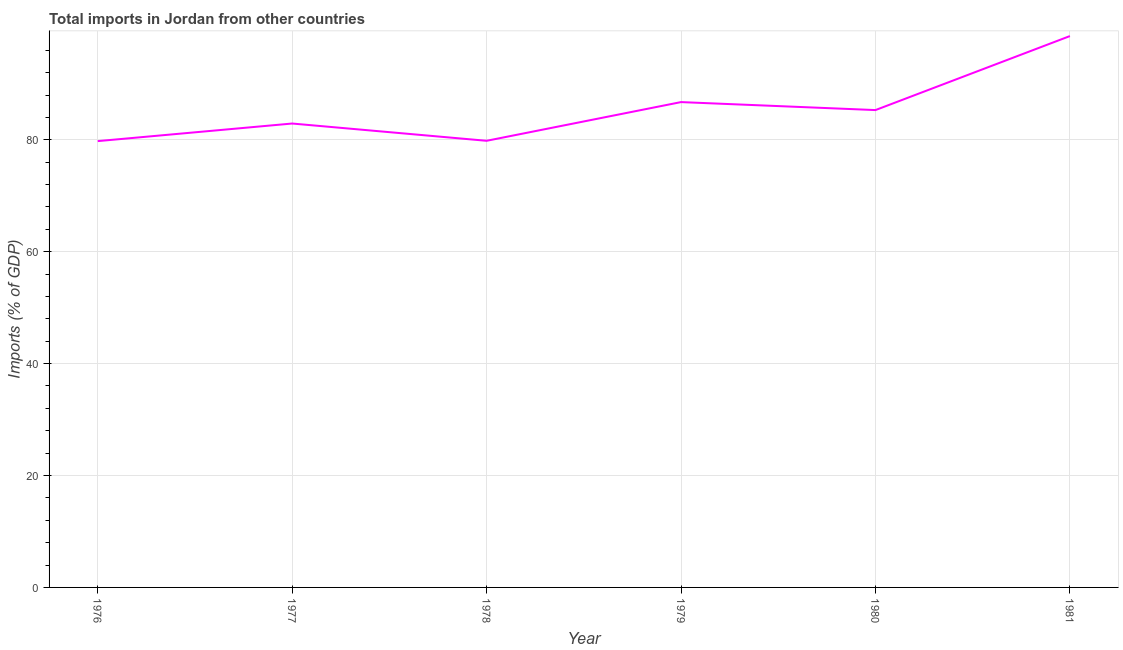What is the total imports in 1977?
Make the answer very short. 82.91. Across all years, what is the maximum total imports?
Give a very brief answer. 98.54. Across all years, what is the minimum total imports?
Provide a succinct answer. 79.76. In which year was the total imports maximum?
Provide a succinct answer. 1981. In which year was the total imports minimum?
Ensure brevity in your answer.  1976. What is the sum of the total imports?
Make the answer very short. 513.08. What is the difference between the total imports in 1977 and 1978?
Give a very brief answer. 3.09. What is the average total imports per year?
Give a very brief answer. 85.51. What is the median total imports?
Offer a terse response. 84.11. Do a majority of the years between 1979 and 1981 (inclusive) have total imports greater than 48 %?
Provide a short and direct response. Yes. What is the ratio of the total imports in 1976 to that in 1979?
Provide a short and direct response. 0.92. What is the difference between the highest and the second highest total imports?
Keep it short and to the point. 11.8. What is the difference between the highest and the lowest total imports?
Give a very brief answer. 18.77. Does the total imports monotonically increase over the years?
Your answer should be compact. No. How many lines are there?
Give a very brief answer. 1. How many years are there in the graph?
Give a very brief answer. 6. What is the difference between two consecutive major ticks on the Y-axis?
Your answer should be very brief. 20. Are the values on the major ticks of Y-axis written in scientific E-notation?
Keep it short and to the point. No. Does the graph contain any zero values?
Your response must be concise. No. What is the title of the graph?
Keep it short and to the point. Total imports in Jordan from other countries. What is the label or title of the X-axis?
Provide a succinct answer. Year. What is the label or title of the Y-axis?
Offer a terse response. Imports (% of GDP). What is the Imports (% of GDP) of 1976?
Provide a succinct answer. 79.76. What is the Imports (% of GDP) in 1977?
Offer a terse response. 82.91. What is the Imports (% of GDP) in 1978?
Make the answer very short. 79.82. What is the Imports (% of GDP) of 1979?
Keep it short and to the point. 86.74. What is the Imports (% of GDP) of 1980?
Make the answer very short. 85.31. What is the Imports (% of GDP) of 1981?
Provide a succinct answer. 98.54. What is the difference between the Imports (% of GDP) in 1976 and 1977?
Make the answer very short. -3.14. What is the difference between the Imports (% of GDP) in 1976 and 1978?
Your answer should be compact. -0.06. What is the difference between the Imports (% of GDP) in 1976 and 1979?
Your answer should be compact. -6.97. What is the difference between the Imports (% of GDP) in 1976 and 1980?
Your response must be concise. -5.55. What is the difference between the Imports (% of GDP) in 1976 and 1981?
Make the answer very short. -18.77. What is the difference between the Imports (% of GDP) in 1977 and 1978?
Give a very brief answer. 3.09. What is the difference between the Imports (% of GDP) in 1977 and 1979?
Offer a terse response. -3.83. What is the difference between the Imports (% of GDP) in 1977 and 1980?
Offer a very short reply. -2.4. What is the difference between the Imports (% of GDP) in 1977 and 1981?
Ensure brevity in your answer.  -15.63. What is the difference between the Imports (% of GDP) in 1978 and 1979?
Ensure brevity in your answer.  -6.92. What is the difference between the Imports (% of GDP) in 1978 and 1980?
Make the answer very short. -5.49. What is the difference between the Imports (% of GDP) in 1978 and 1981?
Offer a terse response. -18.72. What is the difference between the Imports (% of GDP) in 1979 and 1980?
Provide a succinct answer. 1.43. What is the difference between the Imports (% of GDP) in 1979 and 1981?
Offer a terse response. -11.8. What is the difference between the Imports (% of GDP) in 1980 and 1981?
Keep it short and to the point. -13.23. What is the ratio of the Imports (% of GDP) in 1976 to that in 1980?
Your response must be concise. 0.94. What is the ratio of the Imports (% of GDP) in 1976 to that in 1981?
Your response must be concise. 0.81. What is the ratio of the Imports (% of GDP) in 1977 to that in 1978?
Your answer should be very brief. 1.04. What is the ratio of the Imports (% of GDP) in 1977 to that in 1979?
Give a very brief answer. 0.96. What is the ratio of the Imports (% of GDP) in 1977 to that in 1980?
Offer a very short reply. 0.97. What is the ratio of the Imports (% of GDP) in 1977 to that in 1981?
Make the answer very short. 0.84. What is the ratio of the Imports (% of GDP) in 1978 to that in 1980?
Give a very brief answer. 0.94. What is the ratio of the Imports (% of GDP) in 1978 to that in 1981?
Your answer should be very brief. 0.81. What is the ratio of the Imports (% of GDP) in 1979 to that in 1980?
Your answer should be very brief. 1.02. What is the ratio of the Imports (% of GDP) in 1980 to that in 1981?
Keep it short and to the point. 0.87. 